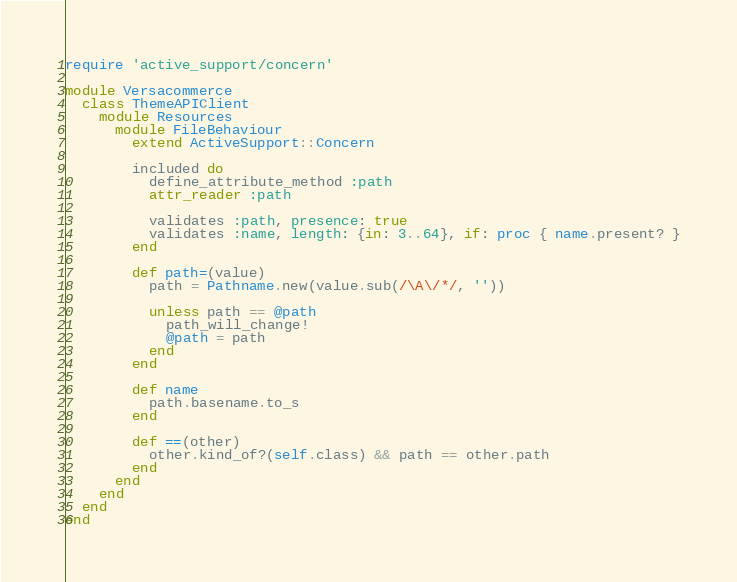<code> <loc_0><loc_0><loc_500><loc_500><_Ruby_>require 'active_support/concern'

module Versacommerce
  class ThemeAPIClient
    module Resources
      module FileBehaviour
        extend ActiveSupport::Concern

        included do
          define_attribute_method :path
          attr_reader :path

          validates :path, presence: true
          validates :name, length: {in: 3..64}, if: proc { name.present? }
        end

        def path=(value)
          path = Pathname.new(value.sub(/\A\/*/, ''))

          unless path == @path
            path_will_change!
            @path = path
          end
        end

        def name
          path.basename.to_s
        end

        def ==(other)
          other.kind_of?(self.class) && path == other.path
        end
      end
    end
  end
end
</code> 